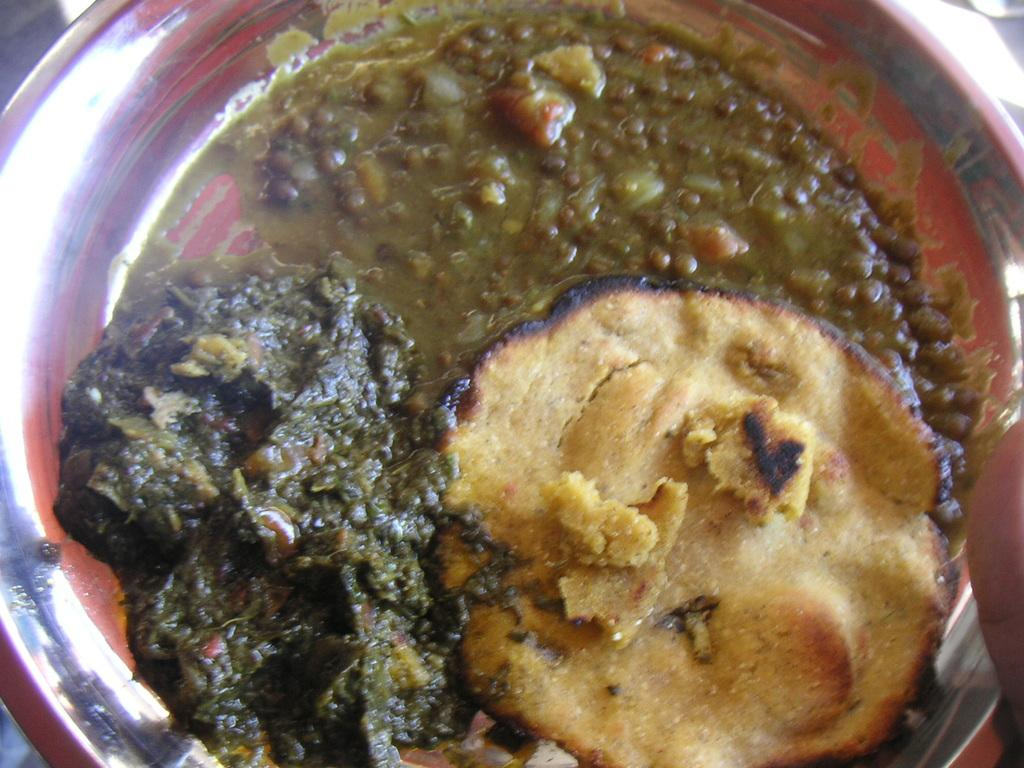What is present in the image that can hold food? There is a bowl in the image that can hold food. What type of food is in the bowl? The bowl contains a food item that has brown, green, and orange colors. What type of dirt can be seen in the image? There is no dirt present in the image. Is there a tent visible in the image? There is no tent present in the image. 